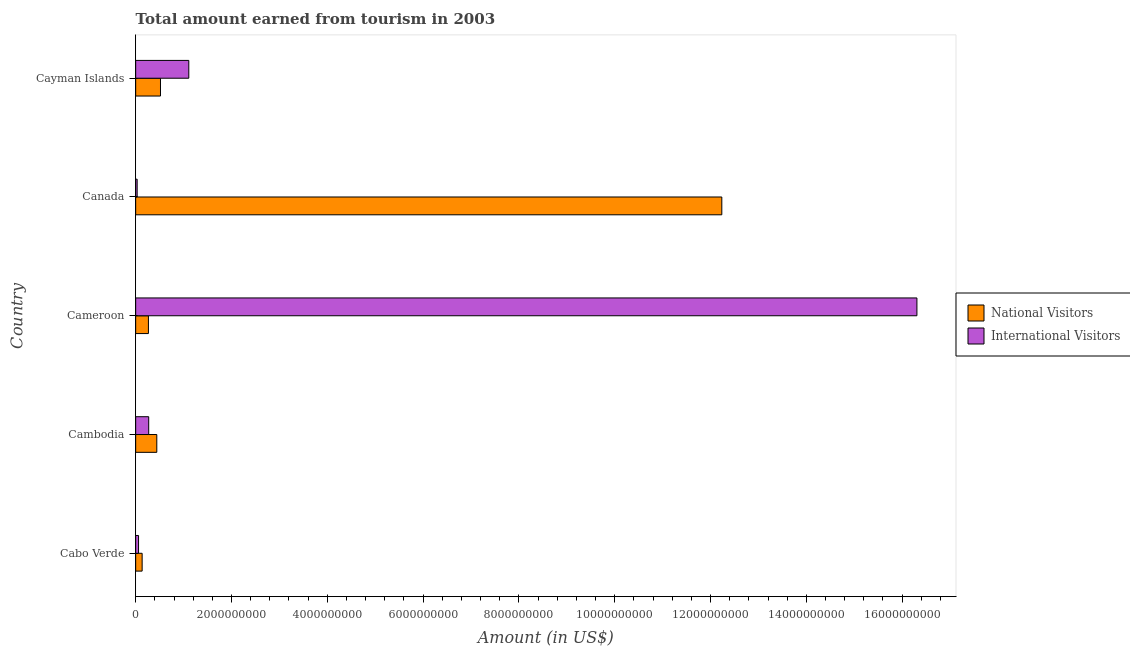How many different coloured bars are there?
Offer a very short reply. 2. Are the number of bars on each tick of the Y-axis equal?
Give a very brief answer. Yes. What is the label of the 3rd group of bars from the top?
Your answer should be very brief. Cameroon. What is the amount earned from international visitors in Cambodia?
Your answer should be very brief. 2.72e+08. Across all countries, what is the maximum amount earned from national visitors?
Your answer should be compact. 1.22e+1. Across all countries, what is the minimum amount earned from international visitors?
Your answer should be very brief. 3.10e+07. In which country was the amount earned from international visitors maximum?
Your answer should be compact. Cameroon. What is the total amount earned from international visitors in the graph?
Provide a succinct answer. 1.78e+1. What is the difference between the amount earned from national visitors in Canada and that in Cayman Islands?
Your response must be concise. 1.17e+1. What is the difference between the amount earned from international visitors in Cameroon and the amount earned from national visitors in Cayman Islands?
Make the answer very short. 1.58e+1. What is the average amount earned from national visitors per country?
Keep it short and to the point. 2.72e+09. What is the difference between the amount earned from international visitors and amount earned from national visitors in Cameroon?
Provide a short and direct response. 1.60e+1. What is the ratio of the amount earned from international visitors in Cameroon to that in Cayman Islands?
Give a very brief answer. 14.71. Is the amount earned from national visitors in Cabo Verde less than that in Cameroon?
Your answer should be compact. Yes. Is the difference between the amount earned from international visitors in Cambodia and Canada greater than the difference between the amount earned from national visitors in Cambodia and Canada?
Provide a succinct answer. Yes. What is the difference between the highest and the second highest amount earned from international visitors?
Provide a short and direct response. 1.52e+1. What is the difference between the highest and the lowest amount earned from international visitors?
Your response must be concise. 1.63e+1. In how many countries, is the amount earned from international visitors greater than the average amount earned from international visitors taken over all countries?
Provide a short and direct response. 1. Is the sum of the amount earned from international visitors in Cabo Verde and Canada greater than the maximum amount earned from national visitors across all countries?
Make the answer very short. No. What does the 1st bar from the top in Cambodia represents?
Give a very brief answer. International Visitors. What does the 2nd bar from the bottom in Canada represents?
Keep it short and to the point. International Visitors. How many bars are there?
Your answer should be very brief. 10. What is the difference between two consecutive major ticks on the X-axis?
Keep it short and to the point. 2.00e+09. Are the values on the major ticks of X-axis written in scientific E-notation?
Offer a very short reply. No. Does the graph contain grids?
Offer a terse response. No. Where does the legend appear in the graph?
Your response must be concise. Center right. What is the title of the graph?
Give a very brief answer. Total amount earned from tourism in 2003. What is the label or title of the X-axis?
Keep it short and to the point. Amount (in US$). What is the label or title of the Y-axis?
Make the answer very short. Country. What is the Amount (in US$) in National Visitors in Cabo Verde?
Provide a short and direct response. 1.35e+08. What is the Amount (in US$) in International Visitors in Cabo Verde?
Offer a very short reply. 6.00e+07. What is the Amount (in US$) of National Visitors in Cambodia?
Ensure brevity in your answer.  4.41e+08. What is the Amount (in US$) in International Visitors in Cambodia?
Provide a short and direct response. 2.72e+08. What is the Amount (in US$) in National Visitors in Cameroon?
Provide a short and direct response. 2.66e+08. What is the Amount (in US$) of International Visitors in Cameroon?
Provide a short and direct response. 1.63e+1. What is the Amount (in US$) of National Visitors in Canada?
Offer a very short reply. 1.22e+1. What is the Amount (in US$) of International Visitors in Canada?
Keep it short and to the point. 3.10e+07. What is the Amount (in US$) of National Visitors in Cayman Islands?
Give a very brief answer. 5.18e+08. What is the Amount (in US$) in International Visitors in Cayman Islands?
Make the answer very short. 1.11e+09. Across all countries, what is the maximum Amount (in US$) in National Visitors?
Your answer should be compact. 1.22e+1. Across all countries, what is the maximum Amount (in US$) of International Visitors?
Provide a short and direct response. 1.63e+1. Across all countries, what is the minimum Amount (in US$) of National Visitors?
Your response must be concise. 1.35e+08. Across all countries, what is the minimum Amount (in US$) in International Visitors?
Ensure brevity in your answer.  3.10e+07. What is the total Amount (in US$) in National Visitors in the graph?
Offer a terse response. 1.36e+1. What is the total Amount (in US$) of International Visitors in the graph?
Give a very brief answer. 1.78e+1. What is the difference between the Amount (in US$) in National Visitors in Cabo Verde and that in Cambodia?
Your response must be concise. -3.06e+08. What is the difference between the Amount (in US$) in International Visitors in Cabo Verde and that in Cambodia?
Keep it short and to the point. -2.12e+08. What is the difference between the Amount (in US$) in National Visitors in Cabo Verde and that in Cameroon?
Your answer should be compact. -1.31e+08. What is the difference between the Amount (in US$) in International Visitors in Cabo Verde and that in Cameroon?
Provide a succinct answer. -1.62e+1. What is the difference between the Amount (in US$) in National Visitors in Cabo Verde and that in Canada?
Keep it short and to the point. -1.21e+1. What is the difference between the Amount (in US$) of International Visitors in Cabo Verde and that in Canada?
Offer a very short reply. 2.90e+07. What is the difference between the Amount (in US$) in National Visitors in Cabo Verde and that in Cayman Islands?
Your response must be concise. -3.83e+08. What is the difference between the Amount (in US$) of International Visitors in Cabo Verde and that in Cayman Islands?
Make the answer very short. -1.05e+09. What is the difference between the Amount (in US$) of National Visitors in Cambodia and that in Cameroon?
Offer a terse response. 1.75e+08. What is the difference between the Amount (in US$) in International Visitors in Cambodia and that in Cameroon?
Provide a short and direct response. -1.60e+1. What is the difference between the Amount (in US$) of National Visitors in Cambodia and that in Canada?
Make the answer very short. -1.18e+1. What is the difference between the Amount (in US$) in International Visitors in Cambodia and that in Canada?
Ensure brevity in your answer.  2.41e+08. What is the difference between the Amount (in US$) of National Visitors in Cambodia and that in Cayman Islands?
Offer a terse response. -7.70e+07. What is the difference between the Amount (in US$) of International Visitors in Cambodia and that in Cayman Islands?
Keep it short and to the point. -8.37e+08. What is the difference between the Amount (in US$) of National Visitors in Cameroon and that in Canada?
Offer a very short reply. -1.20e+1. What is the difference between the Amount (in US$) in International Visitors in Cameroon and that in Canada?
Ensure brevity in your answer.  1.63e+1. What is the difference between the Amount (in US$) of National Visitors in Cameroon and that in Cayman Islands?
Make the answer very short. -2.52e+08. What is the difference between the Amount (in US$) of International Visitors in Cameroon and that in Cayman Islands?
Your answer should be compact. 1.52e+1. What is the difference between the Amount (in US$) of National Visitors in Canada and that in Cayman Islands?
Make the answer very short. 1.17e+1. What is the difference between the Amount (in US$) in International Visitors in Canada and that in Cayman Islands?
Your answer should be compact. -1.08e+09. What is the difference between the Amount (in US$) of National Visitors in Cabo Verde and the Amount (in US$) of International Visitors in Cambodia?
Keep it short and to the point. -1.37e+08. What is the difference between the Amount (in US$) of National Visitors in Cabo Verde and the Amount (in US$) of International Visitors in Cameroon?
Provide a short and direct response. -1.62e+1. What is the difference between the Amount (in US$) of National Visitors in Cabo Verde and the Amount (in US$) of International Visitors in Canada?
Give a very brief answer. 1.04e+08. What is the difference between the Amount (in US$) in National Visitors in Cabo Verde and the Amount (in US$) in International Visitors in Cayman Islands?
Keep it short and to the point. -9.74e+08. What is the difference between the Amount (in US$) in National Visitors in Cambodia and the Amount (in US$) in International Visitors in Cameroon?
Your answer should be very brief. -1.59e+1. What is the difference between the Amount (in US$) in National Visitors in Cambodia and the Amount (in US$) in International Visitors in Canada?
Ensure brevity in your answer.  4.10e+08. What is the difference between the Amount (in US$) in National Visitors in Cambodia and the Amount (in US$) in International Visitors in Cayman Islands?
Offer a very short reply. -6.68e+08. What is the difference between the Amount (in US$) of National Visitors in Cameroon and the Amount (in US$) of International Visitors in Canada?
Give a very brief answer. 2.35e+08. What is the difference between the Amount (in US$) in National Visitors in Cameroon and the Amount (in US$) in International Visitors in Cayman Islands?
Offer a very short reply. -8.43e+08. What is the difference between the Amount (in US$) in National Visitors in Canada and the Amount (in US$) in International Visitors in Cayman Islands?
Give a very brief answer. 1.11e+1. What is the average Amount (in US$) of National Visitors per country?
Your response must be concise. 2.72e+09. What is the average Amount (in US$) in International Visitors per country?
Your response must be concise. 3.56e+09. What is the difference between the Amount (in US$) of National Visitors and Amount (in US$) of International Visitors in Cabo Verde?
Offer a terse response. 7.50e+07. What is the difference between the Amount (in US$) of National Visitors and Amount (in US$) of International Visitors in Cambodia?
Your response must be concise. 1.69e+08. What is the difference between the Amount (in US$) of National Visitors and Amount (in US$) of International Visitors in Cameroon?
Your response must be concise. -1.60e+1. What is the difference between the Amount (in US$) of National Visitors and Amount (in US$) of International Visitors in Canada?
Your answer should be compact. 1.22e+1. What is the difference between the Amount (in US$) of National Visitors and Amount (in US$) of International Visitors in Cayman Islands?
Provide a succinct answer. -5.91e+08. What is the ratio of the Amount (in US$) of National Visitors in Cabo Verde to that in Cambodia?
Your answer should be compact. 0.31. What is the ratio of the Amount (in US$) in International Visitors in Cabo Verde to that in Cambodia?
Offer a terse response. 0.22. What is the ratio of the Amount (in US$) in National Visitors in Cabo Verde to that in Cameroon?
Provide a succinct answer. 0.51. What is the ratio of the Amount (in US$) of International Visitors in Cabo Verde to that in Cameroon?
Your response must be concise. 0. What is the ratio of the Amount (in US$) in National Visitors in Cabo Verde to that in Canada?
Make the answer very short. 0.01. What is the ratio of the Amount (in US$) in International Visitors in Cabo Verde to that in Canada?
Give a very brief answer. 1.94. What is the ratio of the Amount (in US$) of National Visitors in Cabo Verde to that in Cayman Islands?
Your answer should be compact. 0.26. What is the ratio of the Amount (in US$) of International Visitors in Cabo Verde to that in Cayman Islands?
Provide a succinct answer. 0.05. What is the ratio of the Amount (in US$) of National Visitors in Cambodia to that in Cameroon?
Make the answer very short. 1.66. What is the ratio of the Amount (in US$) in International Visitors in Cambodia to that in Cameroon?
Give a very brief answer. 0.02. What is the ratio of the Amount (in US$) of National Visitors in Cambodia to that in Canada?
Your answer should be compact. 0.04. What is the ratio of the Amount (in US$) of International Visitors in Cambodia to that in Canada?
Keep it short and to the point. 8.77. What is the ratio of the Amount (in US$) of National Visitors in Cambodia to that in Cayman Islands?
Offer a terse response. 0.85. What is the ratio of the Amount (in US$) of International Visitors in Cambodia to that in Cayman Islands?
Provide a short and direct response. 0.25. What is the ratio of the Amount (in US$) in National Visitors in Cameroon to that in Canada?
Provide a short and direct response. 0.02. What is the ratio of the Amount (in US$) of International Visitors in Cameroon to that in Canada?
Give a very brief answer. 526.1. What is the ratio of the Amount (in US$) of National Visitors in Cameroon to that in Cayman Islands?
Provide a succinct answer. 0.51. What is the ratio of the Amount (in US$) in International Visitors in Cameroon to that in Cayman Islands?
Your response must be concise. 14.71. What is the ratio of the Amount (in US$) of National Visitors in Canada to that in Cayman Islands?
Offer a terse response. 23.62. What is the ratio of the Amount (in US$) of International Visitors in Canada to that in Cayman Islands?
Provide a succinct answer. 0.03. What is the difference between the highest and the second highest Amount (in US$) of National Visitors?
Offer a very short reply. 1.17e+1. What is the difference between the highest and the second highest Amount (in US$) of International Visitors?
Ensure brevity in your answer.  1.52e+1. What is the difference between the highest and the lowest Amount (in US$) in National Visitors?
Your answer should be compact. 1.21e+1. What is the difference between the highest and the lowest Amount (in US$) of International Visitors?
Offer a very short reply. 1.63e+1. 